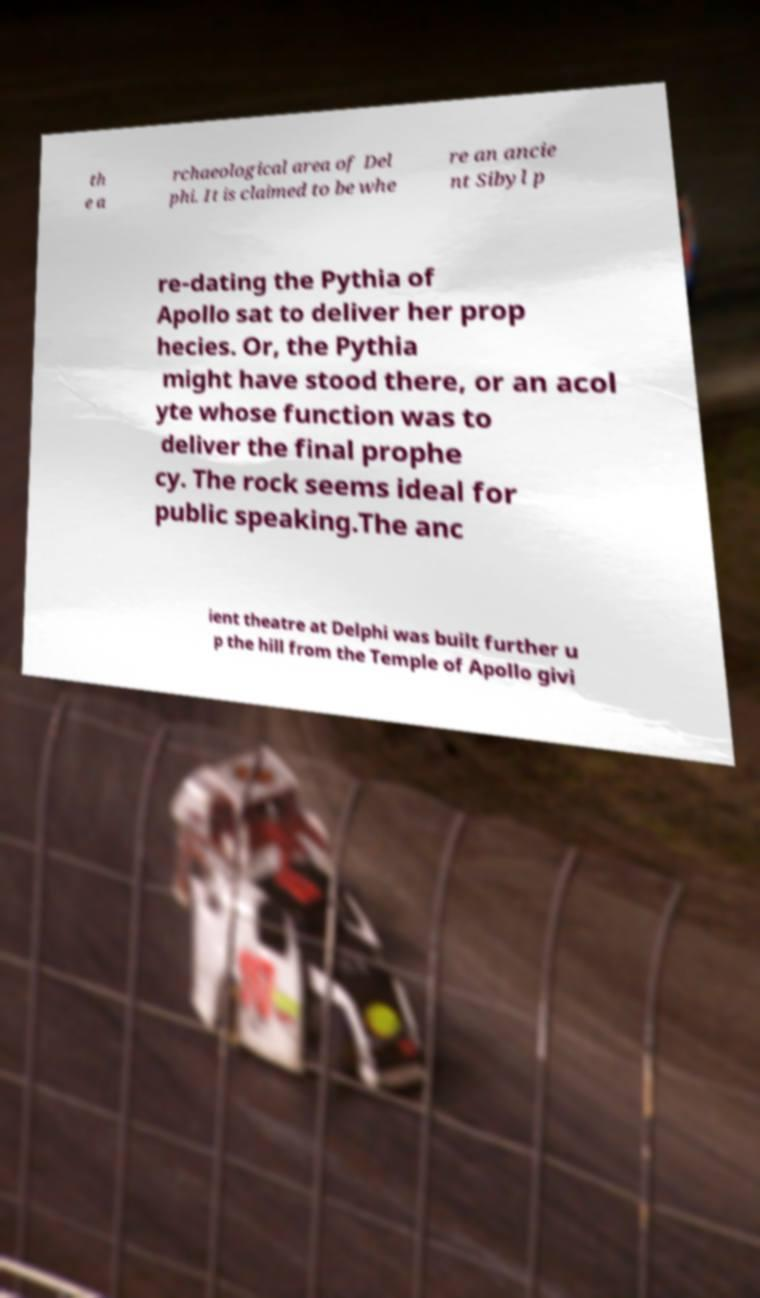Please read and relay the text visible in this image. What does it say? th e a rchaeological area of Del phi. It is claimed to be whe re an ancie nt Sibyl p re-dating the Pythia of Apollo sat to deliver her prop hecies. Or, the Pythia might have stood there, or an acol yte whose function was to deliver the final prophe cy. The rock seems ideal for public speaking.The anc ient theatre at Delphi was built further u p the hill from the Temple of Apollo givi 